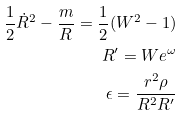Convert formula to latex. <formula><loc_0><loc_0><loc_500><loc_500>\frac { 1 } { 2 } \dot { R } ^ { 2 } - \frac { m } { R } = \frac { 1 } { 2 } ( W ^ { 2 } - 1 ) \\ R ^ { \prime } = W e ^ { \omega } \\ \epsilon = \frac { r ^ { 2 } \rho } { R ^ { 2 } R ^ { \prime } }</formula> 